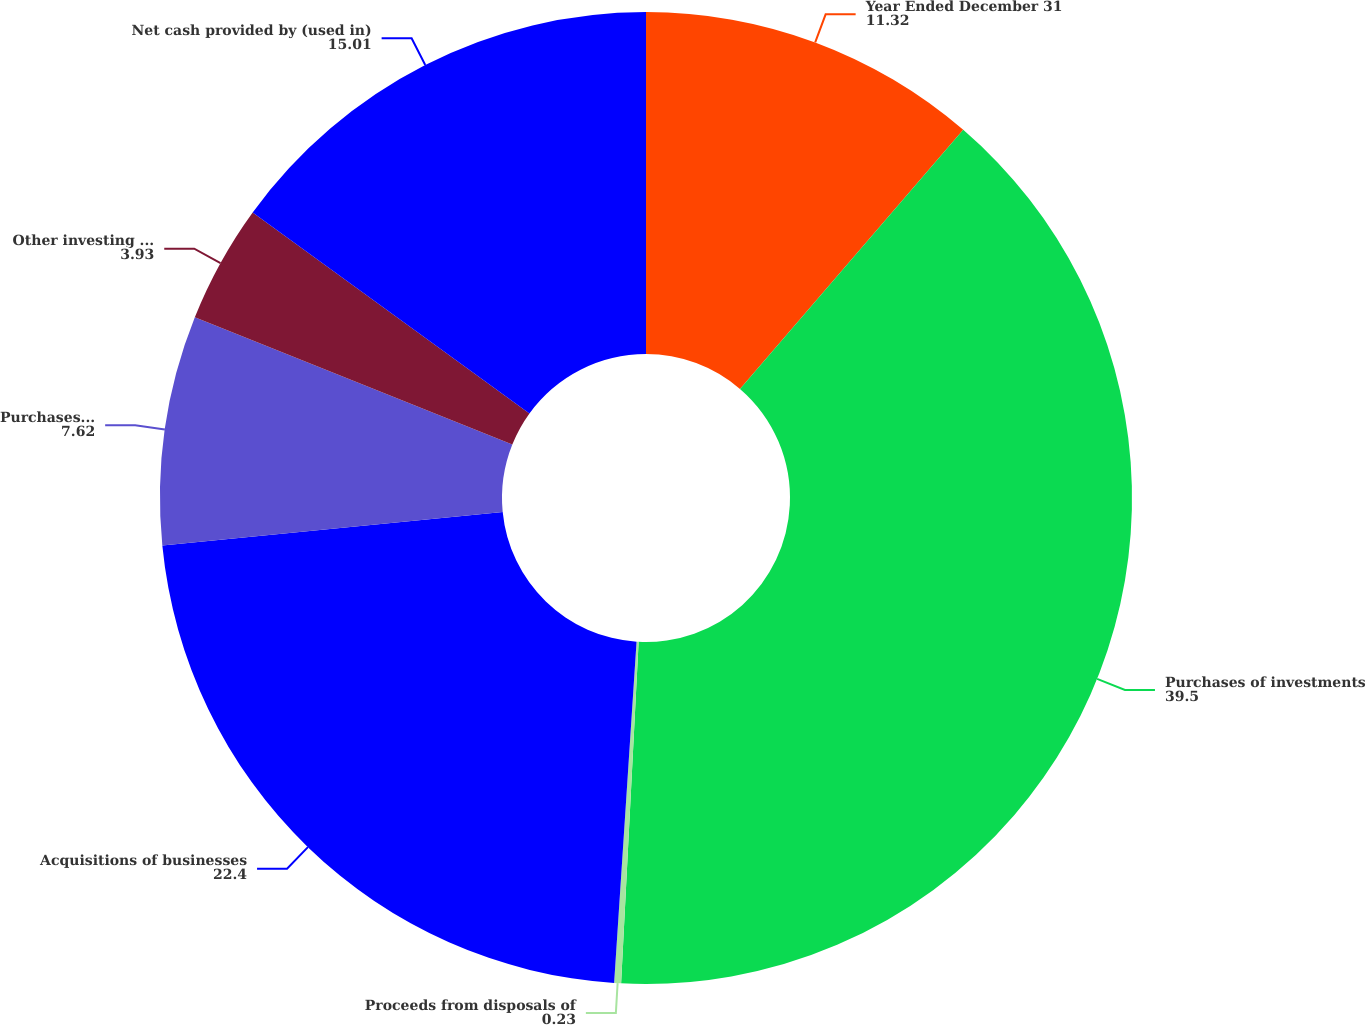Convert chart. <chart><loc_0><loc_0><loc_500><loc_500><pie_chart><fcel>Year Ended December 31<fcel>Purchases of investments<fcel>Proceeds from disposals of<fcel>Acquisitions of businesses<fcel>Purchases of property plant<fcel>Other investing activities<fcel>Net cash provided by (used in)<nl><fcel>11.32%<fcel>39.5%<fcel>0.23%<fcel>22.4%<fcel>7.62%<fcel>3.93%<fcel>15.01%<nl></chart> 